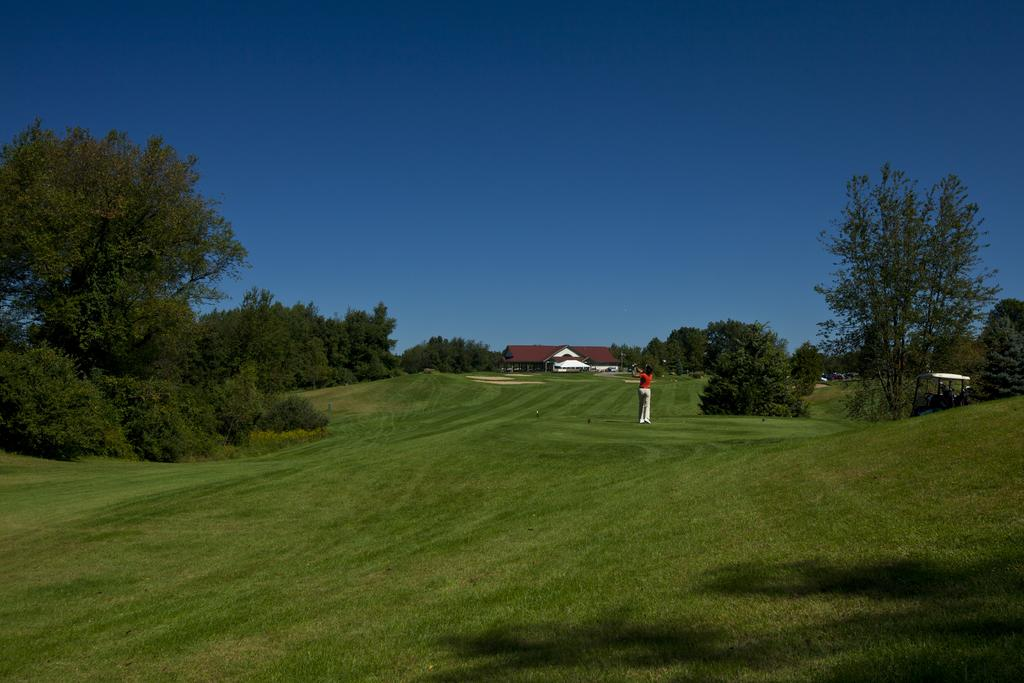What is the person in the image standing on? The person is standing on the grass. What type of natural environment is visible in the image? There are trees visible in the image. What mode of transportation can be seen in the image? A vehicle is present in the image. What type of structure is visible in the image? There is a house in the image. What is the condition of the sky in the image? The sky is clear and visible in the background. What type of error can be seen in the image? There is no error present in the image. Can you see the ocean in the image? No, the image does not show the ocean; it features a person standing on grass, trees, a vehicle, a house, and a clear sky. 